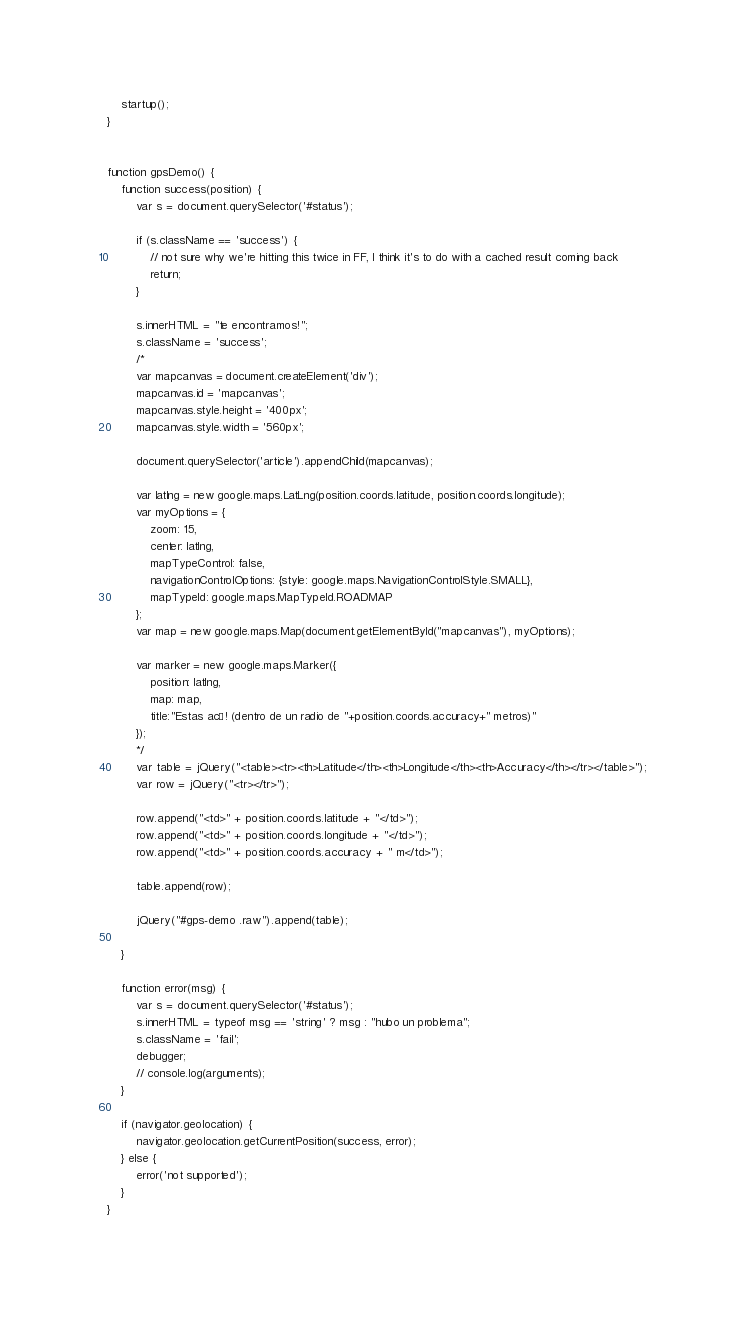<code> <loc_0><loc_0><loc_500><loc_500><_JavaScript_>
    startup();
}


function gpsDemo() {
    function success(position) {
        var s = document.querySelector('#status');

        if (s.className == 'success') {
            // not sure why we're hitting this twice in FF, I think it's to do with a cached result coming back
            return;
        }

        s.innerHTML = "te encontramos!";
        s.className = 'success';
        /*
        var mapcanvas = document.createElement('div');
        mapcanvas.id = 'mapcanvas';
        mapcanvas.style.height = '400px';
        mapcanvas.style.width = '560px';

        document.querySelector('article').appendChild(mapcanvas);

        var latlng = new google.maps.LatLng(position.coords.latitude, position.coords.longitude);
        var myOptions = {
            zoom: 15,
            center: latlng,
            mapTypeControl: false,
            navigationControlOptions: {style: google.maps.NavigationControlStyle.SMALL},
            mapTypeId: google.maps.MapTypeId.ROADMAP
        };
        var map = new google.maps.Map(document.getElementById("mapcanvas"), myOptions);

        var marker = new google.maps.Marker({
            position: latlng,
            map: map,
            title:"Estas acá! (dentro de un radio de "+position.coords.accuracy+" metros)"
        });
        */
        var table = jQuery("<table><tr><th>Latitude</th><th>Longitude</th><th>Accuracy</th></tr></table>");
        var row = jQuery("<tr></tr>");

        row.append("<td>" + position.coords.latitude + "</td>");
        row.append("<td>" + position.coords.longitude + "</td>");
        row.append("<td>" + position.coords.accuracy + " m</td>");

        table.append(row);

        jQuery("#gps-demo .raw").append(table);

    }

    function error(msg) {
        var s = document.querySelector('#status');
        s.innerHTML = typeof msg == 'string' ? msg : "hubo un problema";
        s.className = 'fail';
        debugger;
        // console.log(arguments);
    }

    if (navigator.geolocation) {
        navigator.geolocation.getCurrentPosition(success, error);
    } else {
        error('not supported');
    }
}
</code> 